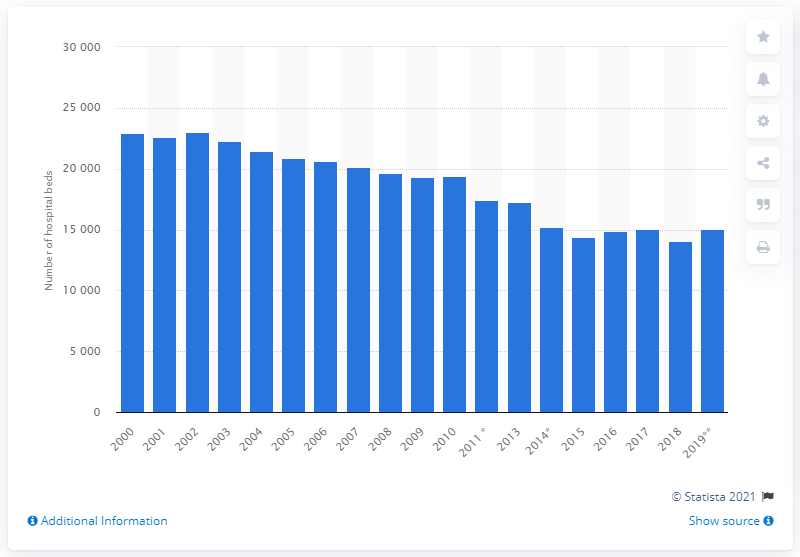Outline some significant characteristics in this image. In 2000, the number of hospital beds in Denmark decreased. In 2019, the total number of hospital beds in Denmark was 15,073. In 2018, the number of hospital beds in Denmark was 14,077. 